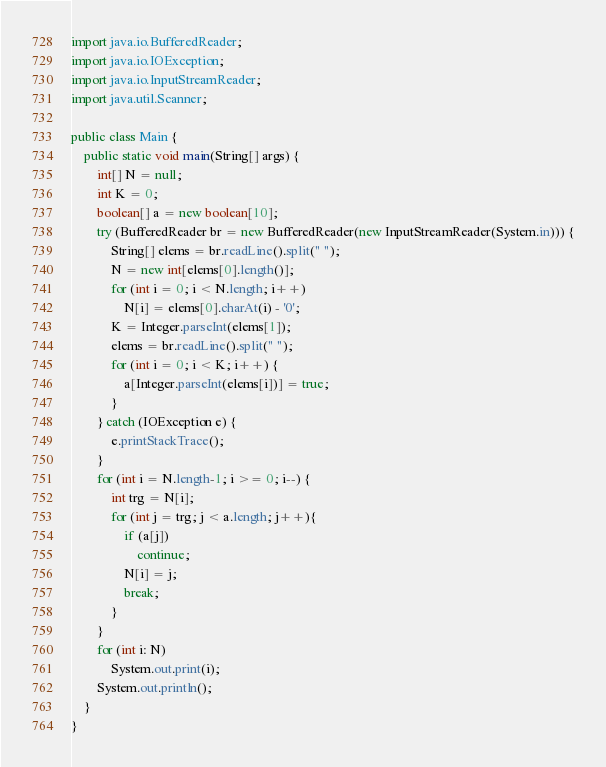<code> <loc_0><loc_0><loc_500><loc_500><_Java_>import java.io.BufferedReader;
import java.io.IOException;
import java.io.InputStreamReader;
import java.util.Scanner;

public class Main {
    public static void main(String[] args) {
        int[] N = null;
        int K = 0;
        boolean[] a = new boolean[10];
        try (BufferedReader br = new BufferedReader(new InputStreamReader(System.in))) {
            String[] elems = br.readLine().split(" ");
            N = new int[elems[0].length()];
            for (int i = 0; i < N.length; i++)
                N[i] = elems[0].charAt(i) - '0';
            K = Integer.parseInt(elems[1]);
            elems = br.readLine().split(" ");
            for (int i = 0; i < K; i++) {
                a[Integer.parseInt(elems[i])] = true;
            }
        } catch (IOException e) {
            e.printStackTrace();
        }
        for (int i = N.length-1; i >= 0; i--) {
            int trg = N[i];
            for (int j = trg; j < a.length; j++){
                if (a[j])
                    continue;
                N[i] = j;
                break;
            }
        }
        for (int i: N)
            System.out.print(i);
        System.out.println();
    }
}
</code> 